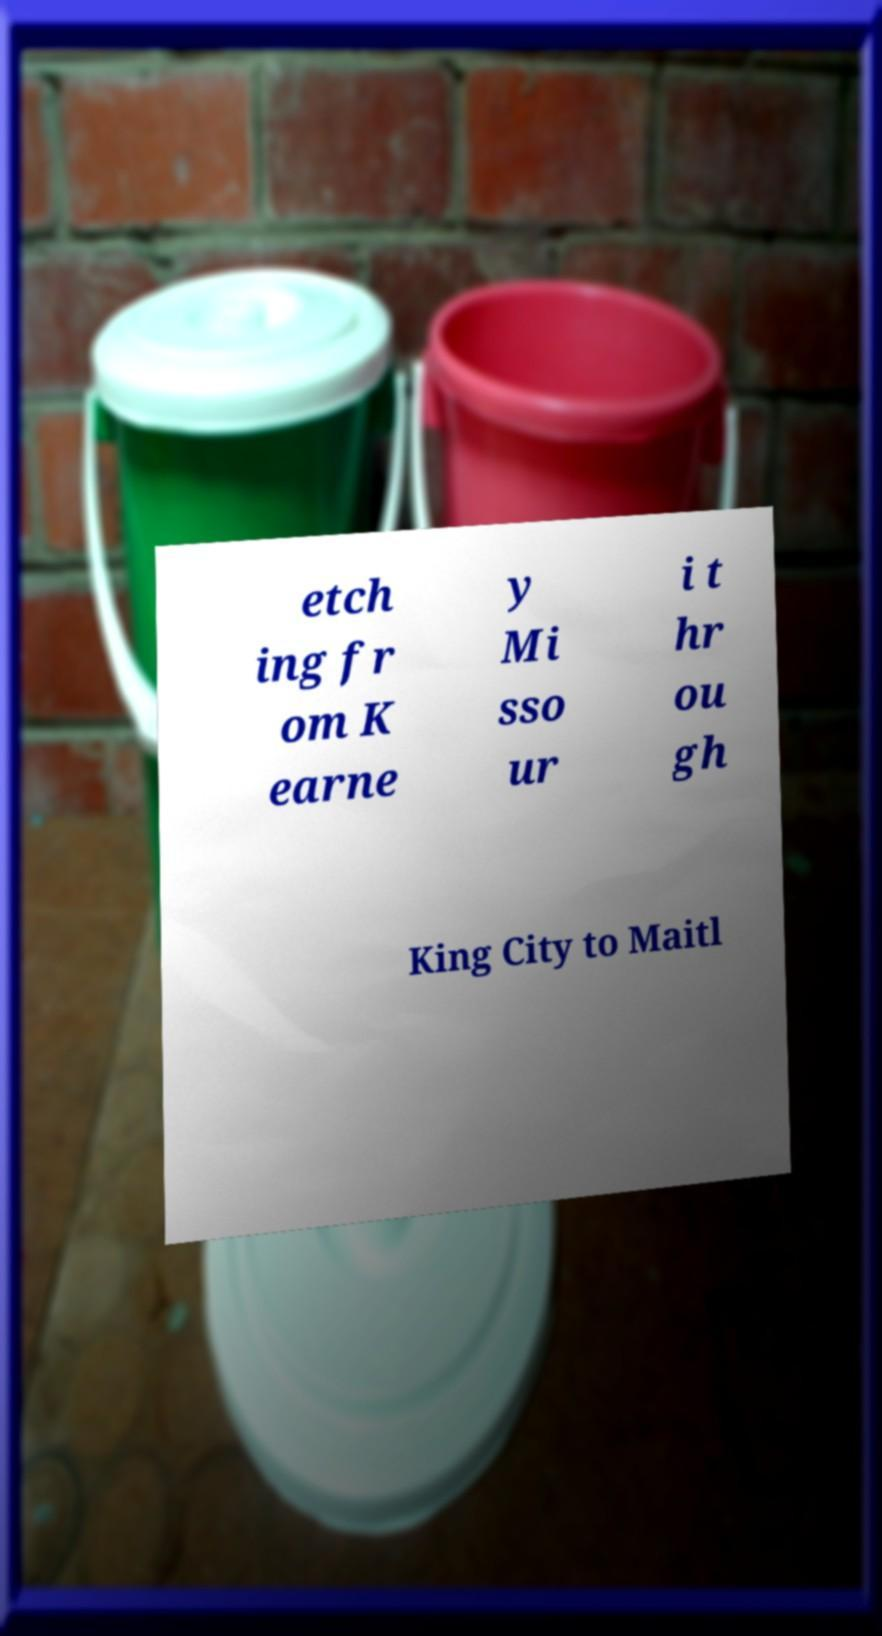Please read and relay the text visible in this image. What does it say? etch ing fr om K earne y Mi sso ur i t hr ou gh King City to Maitl 